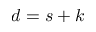Convert formula to latex. <formula><loc_0><loc_0><loc_500><loc_500>d = s + k</formula> 